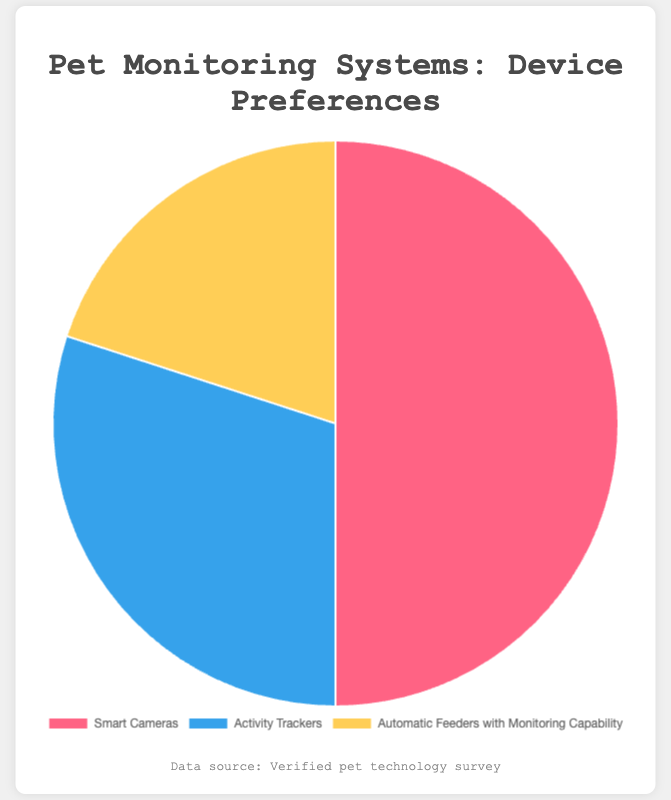What percentage of users prefer Smart Cameras for pet monitoring? The pie chart shows the distribution of device preferences among users. The section of the pie chart labeled "Smart Cameras" represents 50% of user preferences.
Answer: 50% What is the combined percentage for users who prefer Activity Trackers and Automatic Feeders with Monitoring Capability? The pie chart shows that 30% of users prefer Activity Trackers, and 20% prefer Automatic Feeders with Monitoring Capability. Adding these two percentages together gives us 30% + 20% = 50%.
Answer: 50% Which device type is the least preferred for pet monitoring? To find the least preferred device type, look at the device with the smallest slice of the pie chart. The "Automatic Feeders with Monitoring Capability" slice is the smallest, representing 20% of preferences.
Answer: Automatic Feeders with Monitoring Capability How much more popular are Smart Cameras compared to Activity Trackers? The pie chart shows that Smart Cameras are preferred by 50% of users, while Activity Trackers are preferred by 30%. The difference in preference is 50% - 30% = 20%.
Answer: 20% Which device type has a preference percentage closest to a third of the total? A third of 100% is approximately 33.33%. The pie chart shows that Activity Trackers have a preference of 30%, which is closest to 33.33% compared to the other device types.
Answer: Activity Trackers What percentage of users do not prefer Smart Cameras? The pie chart shows that 50% of users prefer Smart Cameras. To find the percentage of users who do not prefer Smart Cameras, subtract this number from 100%. 100% - 50% = 50%.
Answer: 50% If you combine the preferences for Activity Trackers and Automatic Feeders with Monitoring Capability, how does this compare to the preference for Smart Cameras? The pie chart shows 30% for Activity Trackers and 20% for Automatic Feeders, adding up to 50%. This combined preference is equal to the preference for Smart Cameras, which is also 50%.
Answer: Equal How many times higher is the preference for Smart Cameras compared to Automatic Feeders with Monitoring Capability? The pie chart shows that Smart Cameras have a preference of 50%, and Automatic Feeders have 20%. To determine how many times higher the preference for Smart Cameras is, divide 50% by 20% (50 ÷ 20 = 2.5).
Answer: 2.5 times Which section of the pie chart is colored blue, and what percentage does it represent? According to the provided colors, the section colored blue represents the "Activity Trackers" device type on the pie chart. This section shows a preference percentage of 30%.
Answer: Activity Trackers, 30% 